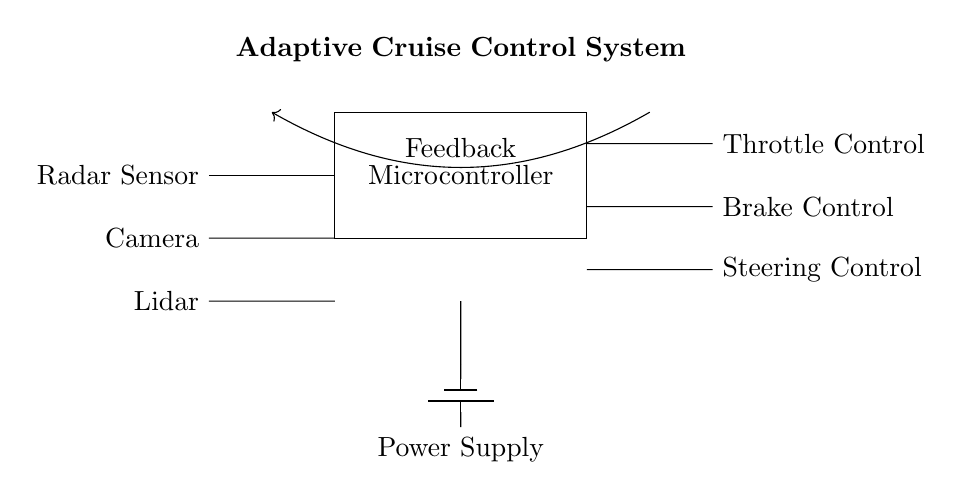What type of sensors are used in this adaptive cruise control system? The diagram shows three types of sensors: Radar Sensor, Camera, and Lidar, indicated by their labels in the circuit.
Answer: Radar Sensor, Camera, Lidar What is the main component that processes data from the sensors? The Microcontroller is labeled in the circuit diagram and acts as the central processing unit for the signals from the sensors.
Answer: Microcontroller What are the three outputs controlled by the microcontroller? The outputs include Throttle Control, Brake Control, and Steering Control, as specified in the diagram next to their respective connections.
Answer: Throttle Control, Brake Control, Steering Control What is the purpose of the feedback indicated in the circuit? The feedback loop connects the output back to the input, allowing the Microcontroller to adjust the system’s actions based on real-time data and maintain safe following distances.
Answer: Adjustments How does the power supply connect to the system? The power supply is illustrated as connected from the battery to the Microcontroller, supplying the required voltage to operate the components.
Answer: Battery to Microcontroller Which component controls the throttle based on sensor data? The Throttle Control is the output connected to the Microcontroller, which processes data and makes decisions for maintaining speed and safe distance.
Answer: Throttle Control 